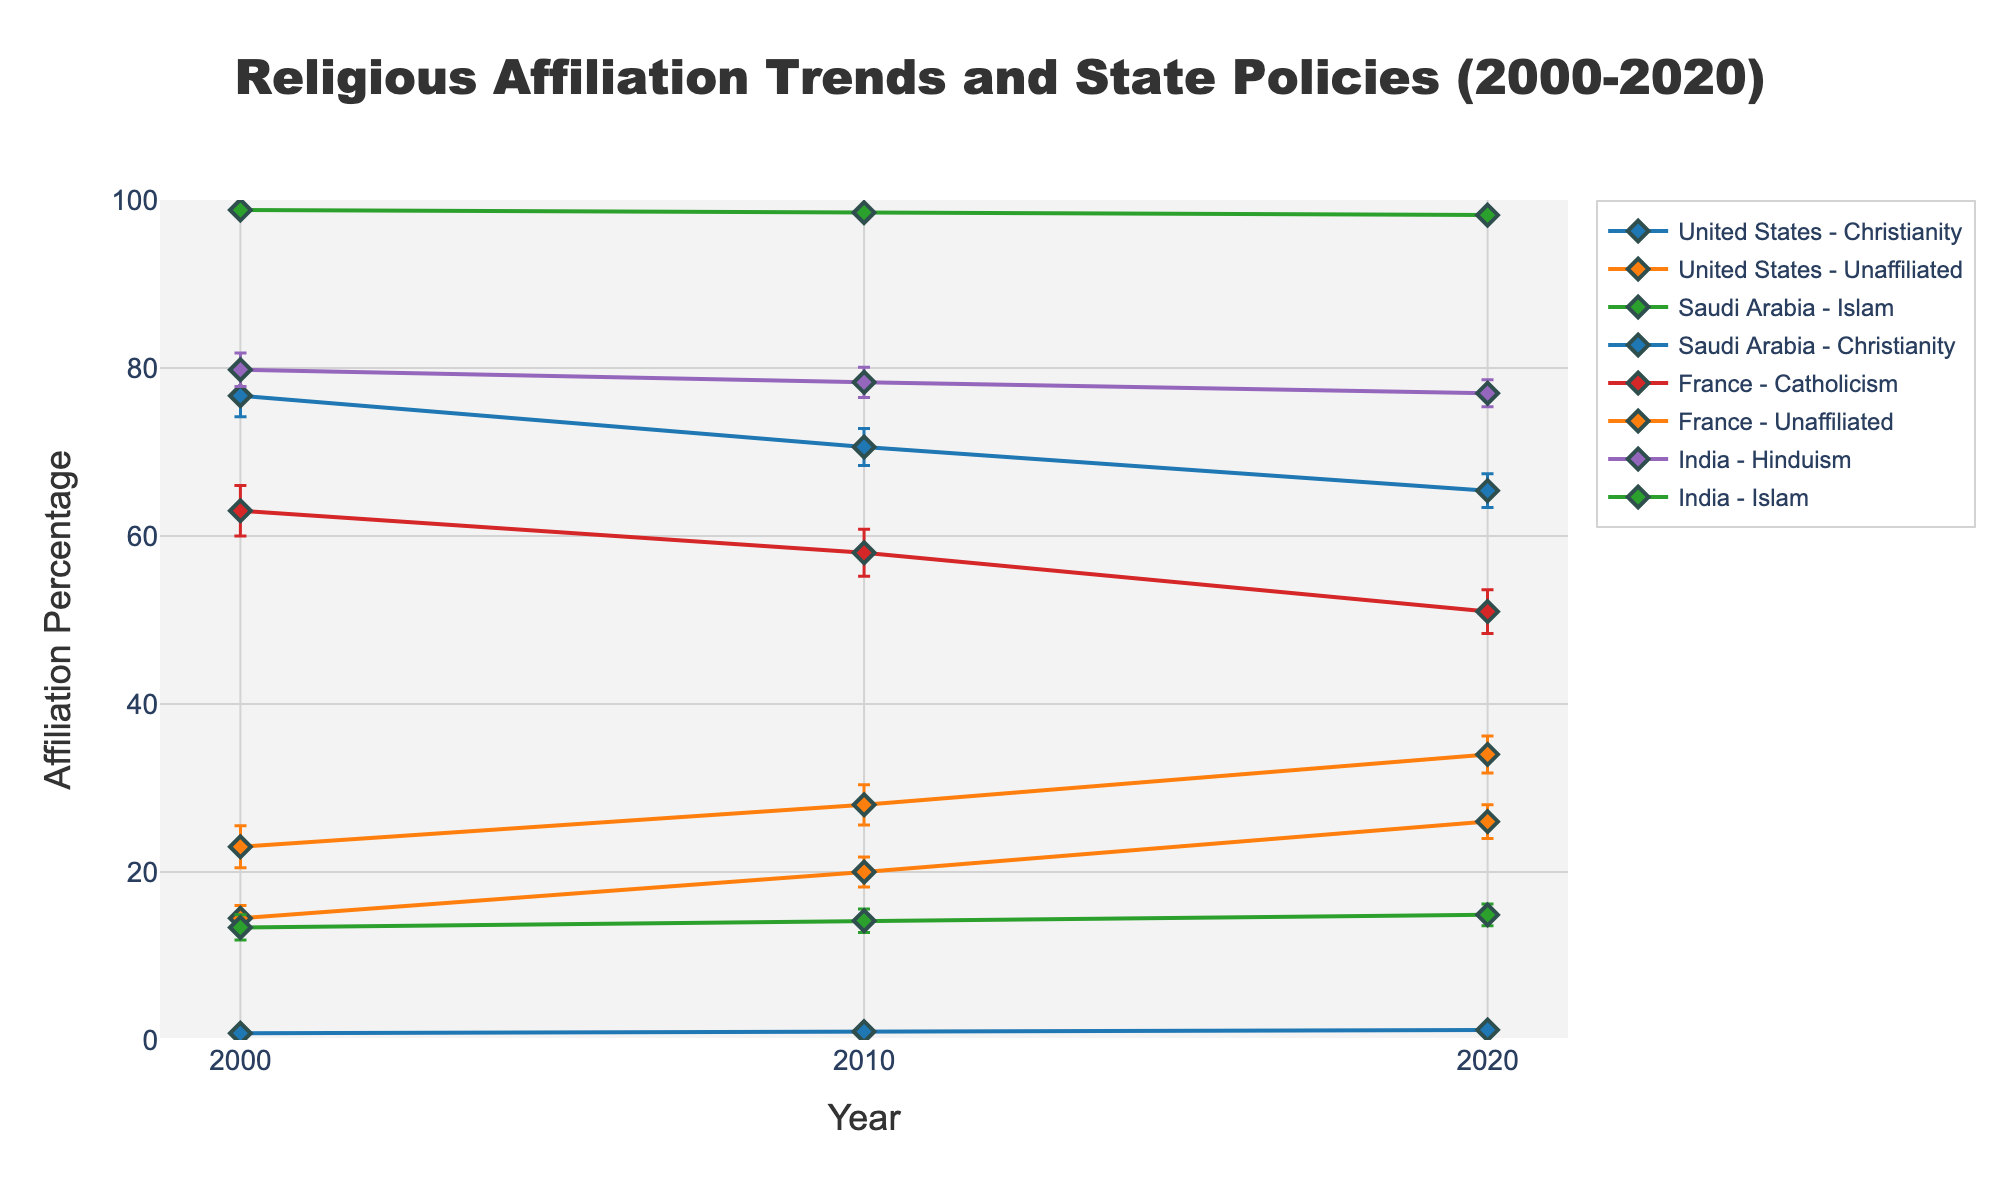What is the title of the figure? The title of the figure is presented at the top and reads: "Religious Affiliation Trends and State Policies (2000-2020)"
Answer: "Religious Affiliation Trends and State Policies (2000-2020)" Which country and religious affiliation have the highest percentage in 2000? Refer to the data points for the year 2000. Saudi Arabia with Islam has the highest percentage at 98.8%.
Answer: Saudi Arabia, Islam What is the percentage change in Christianity in the United States from 2000 to 2020? The percentage for Christianity in the U.S. was 76.7% in 2000 and 65.4% in 2020. The change is 76.7% - 65.4% = 11.3%.
Answer: -11.3% Between 2010 and 2020, which religious affiliation in France saw the highest increase in percentage? Compare the data points for both years. Unaffiliated increased from 28.0% in 2010 to 34.0% in 2020, which is the highest increase of 34.0% - 28.0% = 6.0%.
Answer: Unaffiliated How does the error margin for Unaffiliated in the U.S. change from 2000 to 2020? The error margin changes from 1.5% in 2000 to 2.0% in 2020. This is an increase of 2.0% - 1.5% = 0.5%.
Answer: Increased by 0.5% In 2020, which religious affiliation has the largest error margin in India? Refer to the error margins for different religious affiliations in 2020 in India. Hinduism has the largest error margin of 1.6%.
Answer: Hinduism Compare the percentage affiliation of Christianity in Saudi Arabia and the United States in 2020. The percentage is 1.2% in Saudi Arabia and 65.4% in the United States. The U.S. has a higher percentage of Christianity.
Answer: The United States What is the trend of Islam in India from 2000 to 2020? The percentage for Islam in India has increased from 13.4% in 2000 to 14.9% in 2020.
Answer: Increasing Which country shows a secular state policy across all years in the data? From the state policy data provided, the United States and France show consistent secular state policies from 2000 to 2020.
Answer: The United States and France 